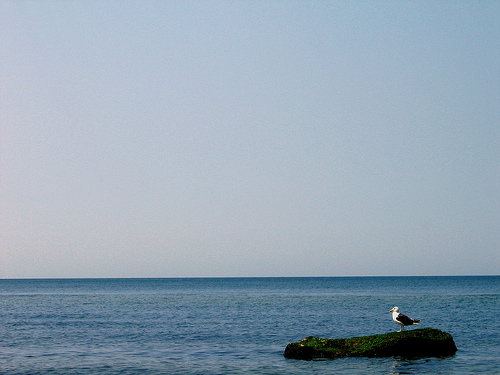<image>
Is there a seagull to the left of the stone? No. The seagull is not to the left of the stone. From this viewpoint, they have a different horizontal relationship. Where is the bird in relation to the water? Is it next to the water? Yes. The bird is positioned adjacent to the water, located nearby in the same general area. 